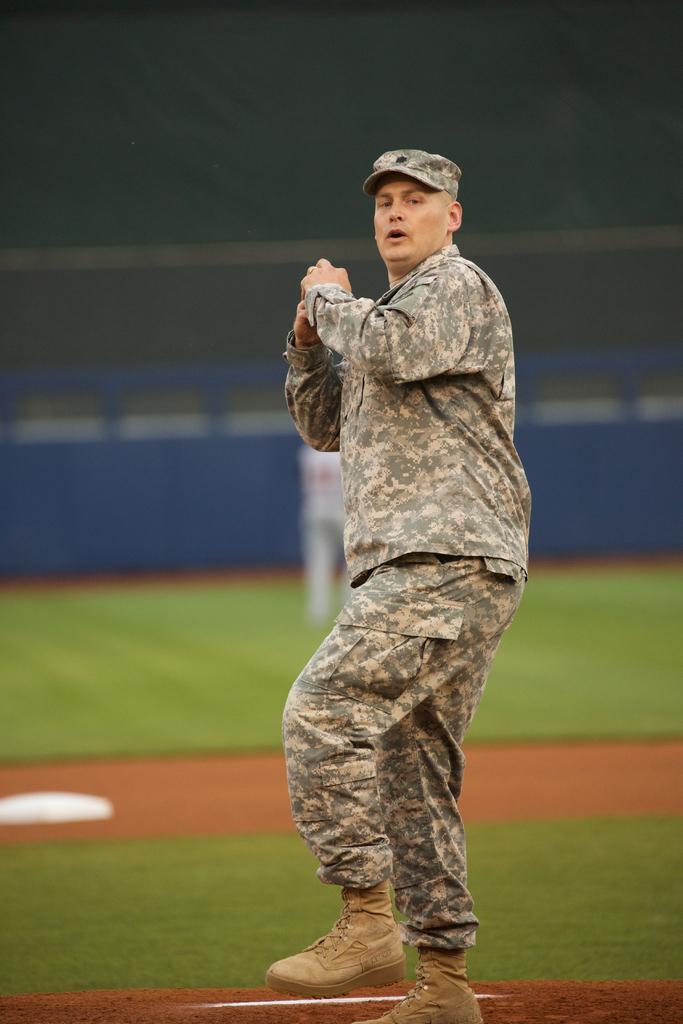In one or two sentences, can you explain what this image depicts? In the center of the image a man is standing. In the background of the image we can see board, ground are present. 